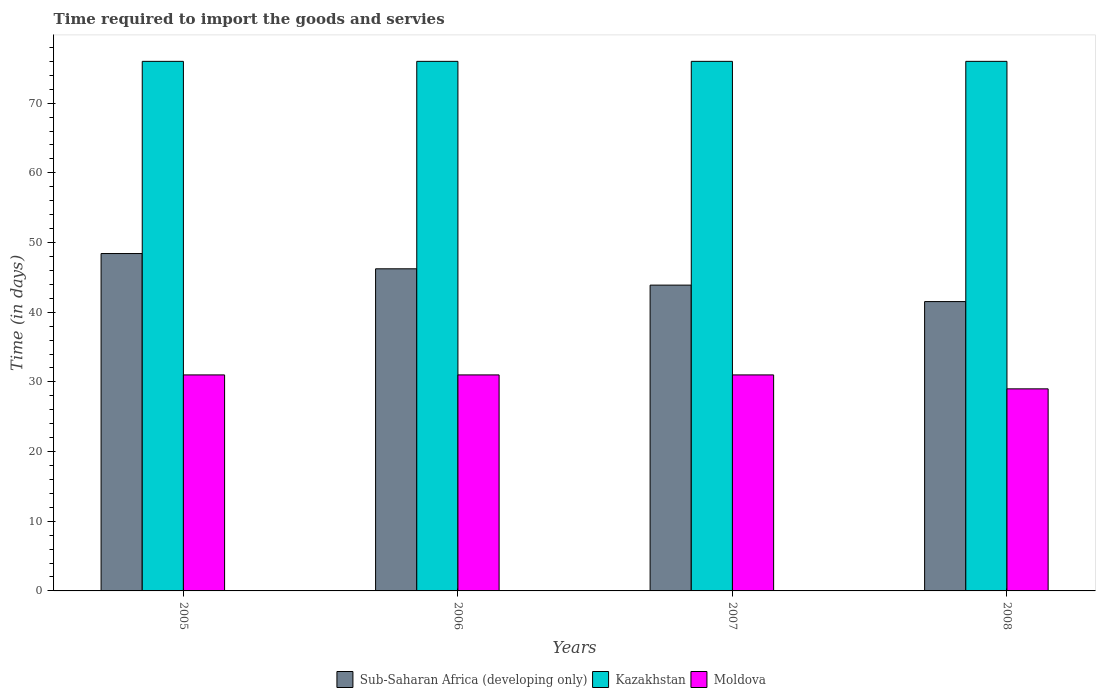How many groups of bars are there?
Offer a terse response. 4. Are the number of bars per tick equal to the number of legend labels?
Your answer should be very brief. Yes. How many bars are there on the 2nd tick from the left?
Offer a very short reply. 3. What is the number of days required to import the goods and services in Kazakhstan in 2006?
Your answer should be very brief. 76. Across all years, what is the maximum number of days required to import the goods and services in Kazakhstan?
Make the answer very short. 76. Across all years, what is the minimum number of days required to import the goods and services in Sub-Saharan Africa (developing only)?
Ensure brevity in your answer.  41.52. In which year was the number of days required to import the goods and services in Sub-Saharan Africa (developing only) minimum?
Your answer should be very brief. 2008. What is the total number of days required to import the goods and services in Sub-Saharan Africa (developing only) in the graph?
Give a very brief answer. 180.05. What is the difference between the number of days required to import the goods and services in Kazakhstan in 2005 and that in 2007?
Make the answer very short. 0. What is the difference between the number of days required to import the goods and services in Moldova in 2008 and the number of days required to import the goods and services in Kazakhstan in 2005?
Give a very brief answer. -47. In the year 2007, what is the difference between the number of days required to import the goods and services in Kazakhstan and number of days required to import the goods and services in Moldova?
Offer a very short reply. 45. In how many years, is the number of days required to import the goods and services in Sub-Saharan Africa (developing only) greater than 2 days?
Provide a short and direct response. 4. What is the difference between the highest and the lowest number of days required to import the goods and services in Kazakhstan?
Give a very brief answer. 0. In how many years, is the number of days required to import the goods and services in Moldova greater than the average number of days required to import the goods and services in Moldova taken over all years?
Keep it short and to the point. 3. Is the sum of the number of days required to import the goods and services in Sub-Saharan Africa (developing only) in 2006 and 2007 greater than the maximum number of days required to import the goods and services in Moldova across all years?
Provide a short and direct response. Yes. What does the 3rd bar from the left in 2007 represents?
Ensure brevity in your answer.  Moldova. What does the 3rd bar from the right in 2006 represents?
Your answer should be very brief. Sub-Saharan Africa (developing only). Are all the bars in the graph horizontal?
Make the answer very short. No. What is the difference between two consecutive major ticks on the Y-axis?
Your response must be concise. 10. Are the values on the major ticks of Y-axis written in scientific E-notation?
Provide a short and direct response. No. Does the graph contain grids?
Offer a terse response. No. Where does the legend appear in the graph?
Provide a succinct answer. Bottom center. How many legend labels are there?
Your response must be concise. 3. What is the title of the graph?
Offer a very short reply. Time required to import the goods and servies. Does "Central African Republic" appear as one of the legend labels in the graph?
Give a very brief answer. No. What is the label or title of the X-axis?
Give a very brief answer. Years. What is the label or title of the Y-axis?
Provide a short and direct response. Time (in days). What is the Time (in days) of Sub-Saharan Africa (developing only) in 2005?
Your answer should be very brief. 48.42. What is the Time (in days) in Moldova in 2005?
Your answer should be very brief. 31. What is the Time (in days) in Sub-Saharan Africa (developing only) in 2006?
Your response must be concise. 46.23. What is the Time (in days) in Kazakhstan in 2006?
Give a very brief answer. 76. What is the Time (in days) of Sub-Saharan Africa (developing only) in 2007?
Offer a very short reply. 43.89. What is the Time (in days) in Kazakhstan in 2007?
Provide a short and direct response. 76. What is the Time (in days) of Sub-Saharan Africa (developing only) in 2008?
Offer a very short reply. 41.52. What is the Time (in days) of Kazakhstan in 2008?
Offer a very short reply. 76. What is the Time (in days) of Moldova in 2008?
Provide a short and direct response. 29. Across all years, what is the maximum Time (in days) in Sub-Saharan Africa (developing only)?
Provide a short and direct response. 48.42. Across all years, what is the maximum Time (in days) in Kazakhstan?
Provide a succinct answer. 76. Across all years, what is the minimum Time (in days) in Sub-Saharan Africa (developing only)?
Ensure brevity in your answer.  41.52. Across all years, what is the minimum Time (in days) of Kazakhstan?
Make the answer very short. 76. What is the total Time (in days) of Sub-Saharan Africa (developing only) in the graph?
Make the answer very short. 180.06. What is the total Time (in days) in Kazakhstan in the graph?
Provide a succinct answer. 304. What is the total Time (in days) in Moldova in the graph?
Your response must be concise. 122. What is the difference between the Time (in days) in Sub-Saharan Africa (developing only) in 2005 and that in 2006?
Offer a terse response. 2.19. What is the difference between the Time (in days) in Kazakhstan in 2005 and that in 2006?
Keep it short and to the point. 0. What is the difference between the Time (in days) of Moldova in 2005 and that in 2006?
Make the answer very short. 0. What is the difference between the Time (in days) in Sub-Saharan Africa (developing only) in 2005 and that in 2007?
Your response must be concise. 4.53. What is the difference between the Time (in days) in Moldova in 2005 and that in 2007?
Offer a very short reply. 0. What is the difference between the Time (in days) in Sub-Saharan Africa (developing only) in 2005 and that in 2008?
Offer a terse response. 6.9. What is the difference between the Time (in days) in Sub-Saharan Africa (developing only) in 2006 and that in 2007?
Make the answer very short. 2.34. What is the difference between the Time (in days) in Kazakhstan in 2006 and that in 2007?
Keep it short and to the point. 0. What is the difference between the Time (in days) of Moldova in 2006 and that in 2007?
Provide a succinct answer. 0. What is the difference between the Time (in days) in Sub-Saharan Africa (developing only) in 2006 and that in 2008?
Your answer should be compact. 4.7. What is the difference between the Time (in days) in Kazakhstan in 2006 and that in 2008?
Your answer should be compact. 0. What is the difference between the Time (in days) in Moldova in 2006 and that in 2008?
Make the answer very short. 2. What is the difference between the Time (in days) of Sub-Saharan Africa (developing only) in 2007 and that in 2008?
Ensure brevity in your answer.  2.36. What is the difference between the Time (in days) in Moldova in 2007 and that in 2008?
Your answer should be very brief. 2. What is the difference between the Time (in days) of Sub-Saharan Africa (developing only) in 2005 and the Time (in days) of Kazakhstan in 2006?
Your response must be concise. -27.58. What is the difference between the Time (in days) in Sub-Saharan Africa (developing only) in 2005 and the Time (in days) in Moldova in 2006?
Offer a very short reply. 17.42. What is the difference between the Time (in days) in Sub-Saharan Africa (developing only) in 2005 and the Time (in days) in Kazakhstan in 2007?
Offer a very short reply. -27.58. What is the difference between the Time (in days) in Sub-Saharan Africa (developing only) in 2005 and the Time (in days) in Moldova in 2007?
Offer a very short reply. 17.42. What is the difference between the Time (in days) of Kazakhstan in 2005 and the Time (in days) of Moldova in 2007?
Keep it short and to the point. 45. What is the difference between the Time (in days) in Sub-Saharan Africa (developing only) in 2005 and the Time (in days) in Kazakhstan in 2008?
Keep it short and to the point. -27.58. What is the difference between the Time (in days) in Sub-Saharan Africa (developing only) in 2005 and the Time (in days) in Moldova in 2008?
Make the answer very short. 19.42. What is the difference between the Time (in days) in Sub-Saharan Africa (developing only) in 2006 and the Time (in days) in Kazakhstan in 2007?
Provide a short and direct response. -29.77. What is the difference between the Time (in days) in Sub-Saharan Africa (developing only) in 2006 and the Time (in days) in Moldova in 2007?
Offer a terse response. 15.23. What is the difference between the Time (in days) of Kazakhstan in 2006 and the Time (in days) of Moldova in 2007?
Ensure brevity in your answer.  45. What is the difference between the Time (in days) of Sub-Saharan Africa (developing only) in 2006 and the Time (in days) of Kazakhstan in 2008?
Your answer should be very brief. -29.77. What is the difference between the Time (in days) of Sub-Saharan Africa (developing only) in 2006 and the Time (in days) of Moldova in 2008?
Your response must be concise. 17.23. What is the difference between the Time (in days) in Kazakhstan in 2006 and the Time (in days) in Moldova in 2008?
Your response must be concise. 47. What is the difference between the Time (in days) of Sub-Saharan Africa (developing only) in 2007 and the Time (in days) of Kazakhstan in 2008?
Make the answer very short. -32.11. What is the difference between the Time (in days) of Sub-Saharan Africa (developing only) in 2007 and the Time (in days) of Moldova in 2008?
Offer a terse response. 14.89. What is the average Time (in days) of Sub-Saharan Africa (developing only) per year?
Offer a terse response. 45.01. What is the average Time (in days) in Moldova per year?
Provide a short and direct response. 30.5. In the year 2005, what is the difference between the Time (in days) in Sub-Saharan Africa (developing only) and Time (in days) in Kazakhstan?
Offer a very short reply. -27.58. In the year 2005, what is the difference between the Time (in days) of Sub-Saharan Africa (developing only) and Time (in days) of Moldova?
Make the answer very short. 17.42. In the year 2005, what is the difference between the Time (in days) of Kazakhstan and Time (in days) of Moldova?
Offer a terse response. 45. In the year 2006, what is the difference between the Time (in days) in Sub-Saharan Africa (developing only) and Time (in days) in Kazakhstan?
Your answer should be very brief. -29.77. In the year 2006, what is the difference between the Time (in days) in Sub-Saharan Africa (developing only) and Time (in days) in Moldova?
Your answer should be compact. 15.23. In the year 2007, what is the difference between the Time (in days) in Sub-Saharan Africa (developing only) and Time (in days) in Kazakhstan?
Your response must be concise. -32.11. In the year 2007, what is the difference between the Time (in days) in Sub-Saharan Africa (developing only) and Time (in days) in Moldova?
Make the answer very short. 12.89. In the year 2007, what is the difference between the Time (in days) in Kazakhstan and Time (in days) in Moldova?
Your answer should be compact. 45. In the year 2008, what is the difference between the Time (in days) in Sub-Saharan Africa (developing only) and Time (in days) in Kazakhstan?
Your answer should be compact. -34.48. In the year 2008, what is the difference between the Time (in days) in Sub-Saharan Africa (developing only) and Time (in days) in Moldova?
Offer a very short reply. 12.52. What is the ratio of the Time (in days) of Sub-Saharan Africa (developing only) in 2005 to that in 2006?
Ensure brevity in your answer.  1.05. What is the ratio of the Time (in days) of Kazakhstan in 2005 to that in 2006?
Make the answer very short. 1. What is the ratio of the Time (in days) of Sub-Saharan Africa (developing only) in 2005 to that in 2007?
Your response must be concise. 1.1. What is the ratio of the Time (in days) in Kazakhstan in 2005 to that in 2007?
Ensure brevity in your answer.  1. What is the ratio of the Time (in days) of Sub-Saharan Africa (developing only) in 2005 to that in 2008?
Provide a short and direct response. 1.17. What is the ratio of the Time (in days) in Kazakhstan in 2005 to that in 2008?
Make the answer very short. 1. What is the ratio of the Time (in days) in Moldova in 2005 to that in 2008?
Ensure brevity in your answer.  1.07. What is the ratio of the Time (in days) of Sub-Saharan Africa (developing only) in 2006 to that in 2007?
Offer a very short reply. 1.05. What is the ratio of the Time (in days) in Moldova in 2006 to that in 2007?
Make the answer very short. 1. What is the ratio of the Time (in days) of Sub-Saharan Africa (developing only) in 2006 to that in 2008?
Offer a terse response. 1.11. What is the ratio of the Time (in days) of Moldova in 2006 to that in 2008?
Provide a short and direct response. 1.07. What is the ratio of the Time (in days) in Sub-Saharan Africa (developing only) in 2007 to that in 2008?
Your answer should be very brief. 1.06. What is the ratio of the Time (in days) in Kazakhstan in 2007 to that in 2008?
Make the answer very short. 1. What is the ratio of the Time (in days) in Moldova in 2007 to that in 2008?
Give a very brief answer. 1.07. What is the difference between the highest and the second highest Time (in days) in Sub-Saharan Africa (developing only)?
Make the answer very short. 2.19. What is the difference between the highest and the second highest Time (in days) in Kazakhstan?
Provide a succinct answer. 0. What is the difference between the highest and the lowest Time (in days) of Sub-Saharan Africa (developing only)?
Offer a terse response. 6.9. What is the difference between the highest and the lowest Time (in days) in Kazakhstan?
Your response must be concise. 0. 